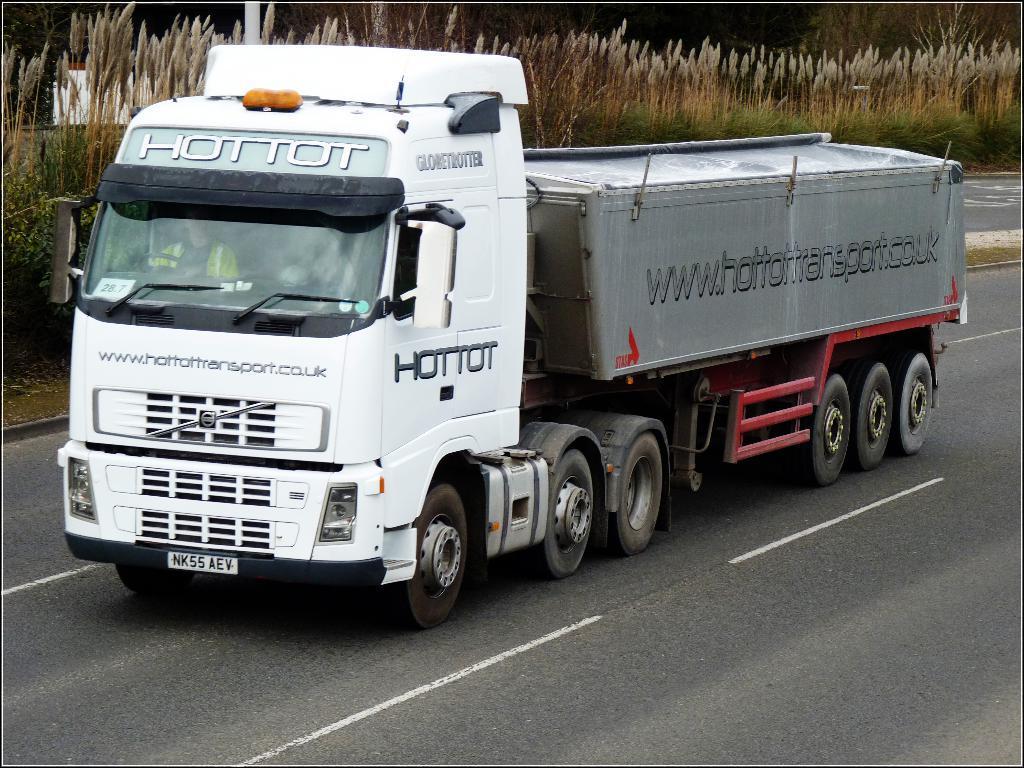In one or two sentences, can you explain what this image depicts? In the foreground of the image we can see a truck on the road. In the background of the image there are crops and trees. 